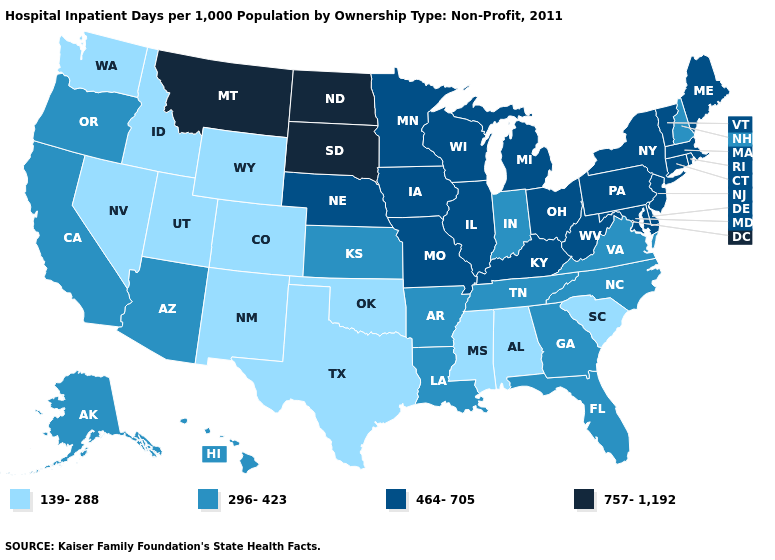Name the states that have a value in the range 757-1,192?
Write a very short answer. Montana, North Dakota, South Dakota. Which states have the highest value in the USA?
Give a very brief answer. Montana, North Dakota, South Dakota. Does the first symbol in the legend represent the smallest category?
Write a very short answer. Yes. What is the value of Virginia?
Be succinct. 296-423. Name the states that have a value in the range 464-705?
Quick response, please. Connecticut, Delaware, Illinois, Iowa, Kentucky, Maine, Maryland, Massachusetts, Michigan, Minnesota, Missouri, Nebraska, New Jersey, New York, Ohio, Pennsylvania, Rhode Island, Vermont, West Virginia, Wisconsin. Which states have the lowest value in the Northeast?
Quick response, please. New Hampshire. Name the states that have a value in the range 139-288?
Answer briefly. Alabama, Colorado, Idaho, Mississippi, Nevada, New Mexico, Oklahoma, South Carolina, Texas, Utah, Washington, Wyoming. Name the states that have a value in the range 757-1,192?
Answer briefly. Montana, North Dakota, South Dakota. Does Delaware have a lower value than Kentucky?
Short answer required. No. Among the states that border Washington , which have the lowest value?
Write a very short answer. Idaho. Does Virginia have the same value as Idaho?
Be succinct. No. Does Illinois have the same value as West Virginia?
Quick response, please. Yes. Name the states that have a value in the range 296-423?
Concise answer only. Alaska, Arizona, Arkansas, California, Florida, Georgia, Hawaii, Indiana, Kansas, Louisiana, New Hampshire, North Carolina, Oregon, Tennessee, Virginia. 